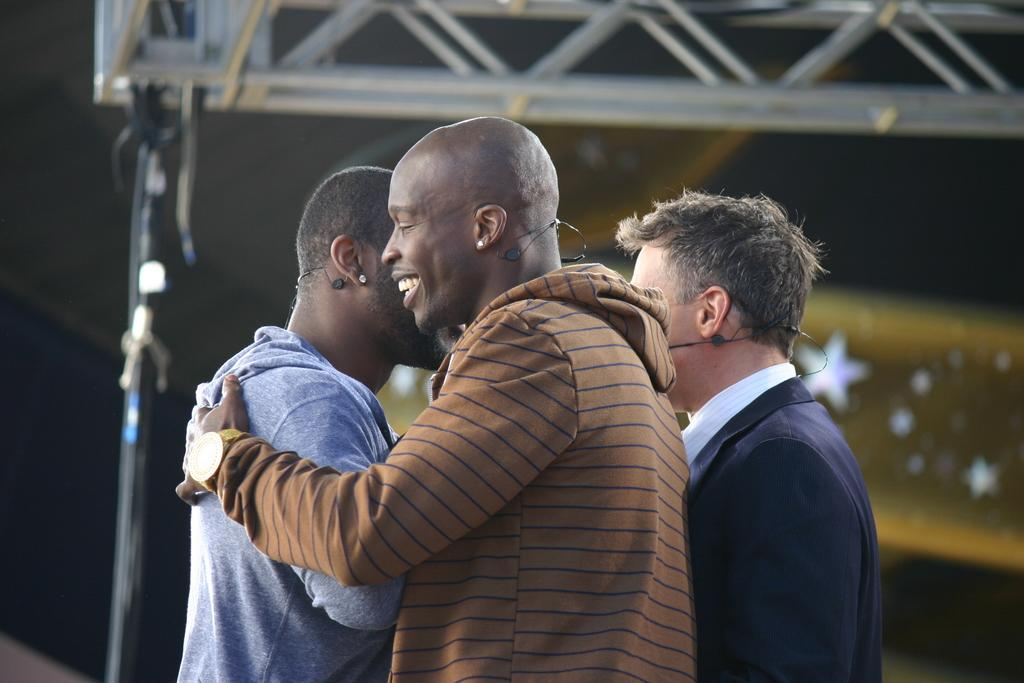Who or what is present in the image? There are people in the image. What are the people wearing? The people are wearing mics. What can be seen in the background of the image? There is a stand and rods visible in the background of the image. How many chickens are present in the image? There are no chickens present in the image. What type of heart can be seen in the image? There is no heart visible in the image. 